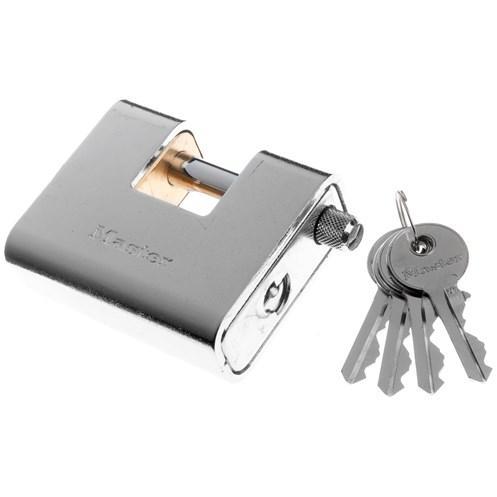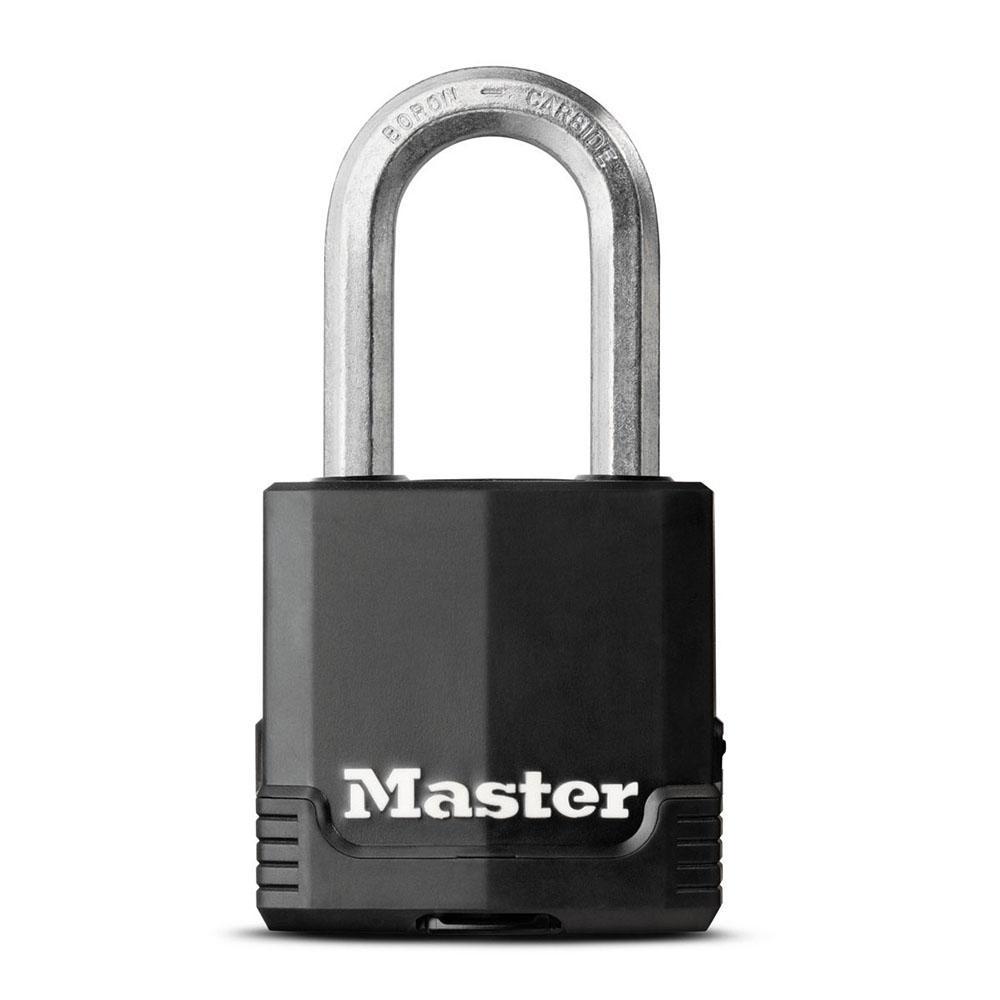The first image is the image on the left, the second image is the image on the right. Given the left and right images, does the statement "There is a pair of gold colored keys beside a lock in one of the images." hold true? Answer yes or no. No. The first image is the image on the left, the second image is the image on the right. For the images displayed, is the sentence "there are two keys next to a lock" factually correct? Answer yes or no. No. 